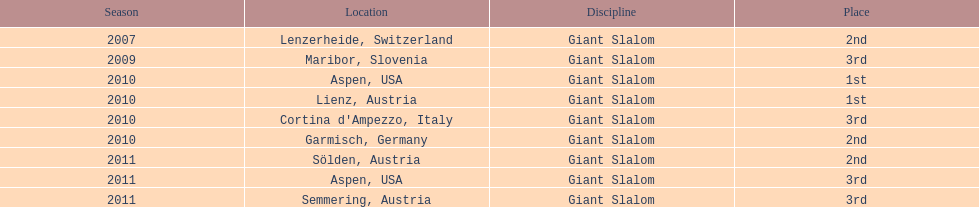At which location did she secure her initial win? Aspen, USA. 